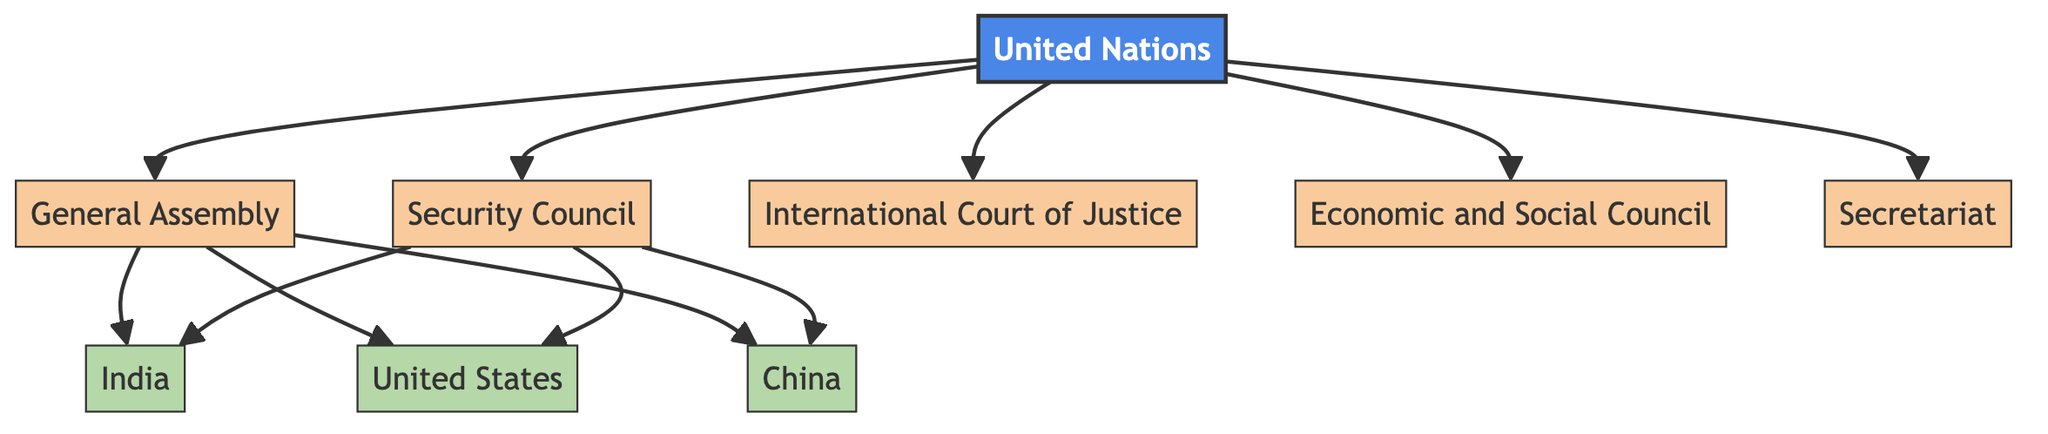What is the main body represented at the top of the diagram? The diagram has a primary node labeled "United Nations." This node acts as the root from which the other sub-nodes (main organs) branch out.
Answer: United Nations How many primary organs of the United Nations are illustrated in the diagram? There are five primary organs depicted in the diagram: General Assembly, Security Council, International Court of Justice, Economic and Social Council, and Secretariat. By counting these sub-nodes, we arrive at the total.
Answer: 5 Which body is responsible for international disputes and legal matters? The diagram has a specific node labeled "International Court of Justice," which is designated for addressing international disputes and legal issues among states.
Answer: International Court of Justice List three countries represented under the General Assembly. The diagram shows three countries connected to the General Assembly node: India, United States, and China. These nodes are directly linked to the General Assembly, indicating their membership.
Answer: India, United States, China How do the members of the Security Council relate to the diagram? The Security Council node connects to the same three countries: India, United States, and China. This indicates that these countries have membership in the Security Council as well. Therefore, the same countries appear in both the General Assembly and Security Council sections.
Answer: India, United States, China What function does the Economic and Social Council serve according to the diagram? While the diagram does not provide extensive detail, the Economic and Social Council is generally understood to handle issues related to economic and social matters within the UN framework. This role can be inferred based on the name, although not explicitly stated in the diagram.
Answer: Economic and social issues Which organ of the United Nations has the role of administrative support? The diagram explicitly shows the "Secretariat" node as part of the main organs. The Secretariat generally provides administrative support for the functioning of the other bodies, as illustrated.
Answer: Secretariat Are all three countries members of both the General Assembly and Security Council? Yes, the diagram demonstrates that India, United States, and China are all connected to both the General Assembly and the Security Council nodes, indicating their membership in both.
Answer: Yes 